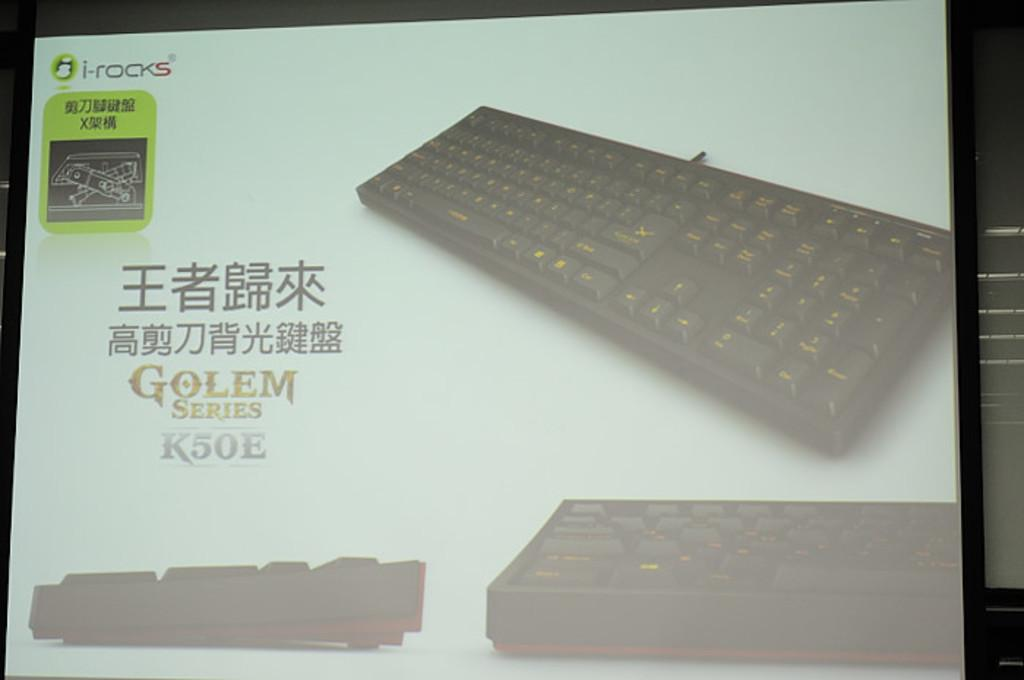<image>
Create a compact narrative representing the image presented. A black keyboard with orange letters in the Golem series. 